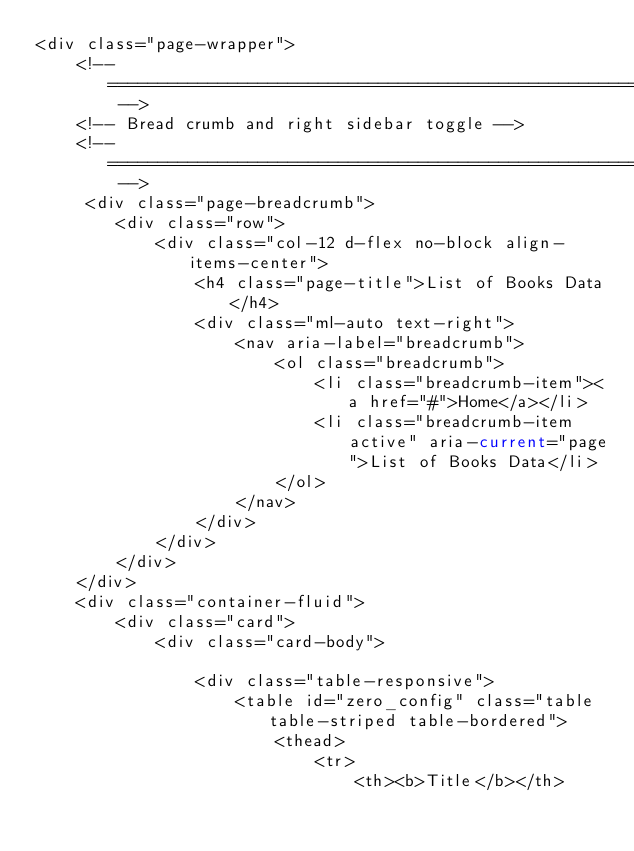Convert code to text. <code><loc_0><loc_0><loc_500><loc_500><_PHP_><div class="page-wrapper">
    <!-- ============================================================== -->
    <!-- Bread crumb and right sidebar toggle -->
    <!-- ============================================================== -->
     <div class="page-breadcrumb">
        <div class="row">
            <div class="col-12 d-flex no-block align-items-center">
                <h4 class="page-title">List of Books Data</h4>
                <div class="ml-auto text-right">
                    <nav aria-label="breadcrumb">
                        <ol class="breadcrumb">
                            <li class="breadcrumb-item"><a href="#">Home</a></li>
                            <li class="breadcrumb-item active" aria-current="page">List of Books Data</li>
                        </ol>
                    </nav>
                </div>
            </div>
        </div>
    </div>
    <div class="container-fluid">
        <div class="card">
            <div class="card-body">

                <div class="table-responsive">
                    <table id="zero_config" class="table table-striped table-bordered">
                        <thead>
                            <tr>
                                <th><b>Title</b></th></code> 